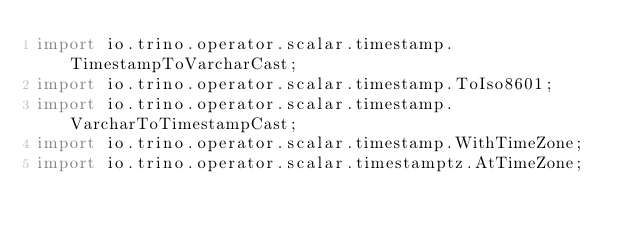Convert code to text. <code><loc_0><loc_0><loc_500><loc_500><_Java_>import io.trino.operator.scalar.timestamp.TimestampToVarcharCast;
import io.trino.operator.scalar.timestamp.ToIso8601;
import io.trino.operator.scalar.timestamp.VarcharToTimestampCast;
import io.trino.operator.scalar.timestamp.WithTimeZone;
import io.trino.operator.scalar.timestamptz.AtTimeZone;</code> 